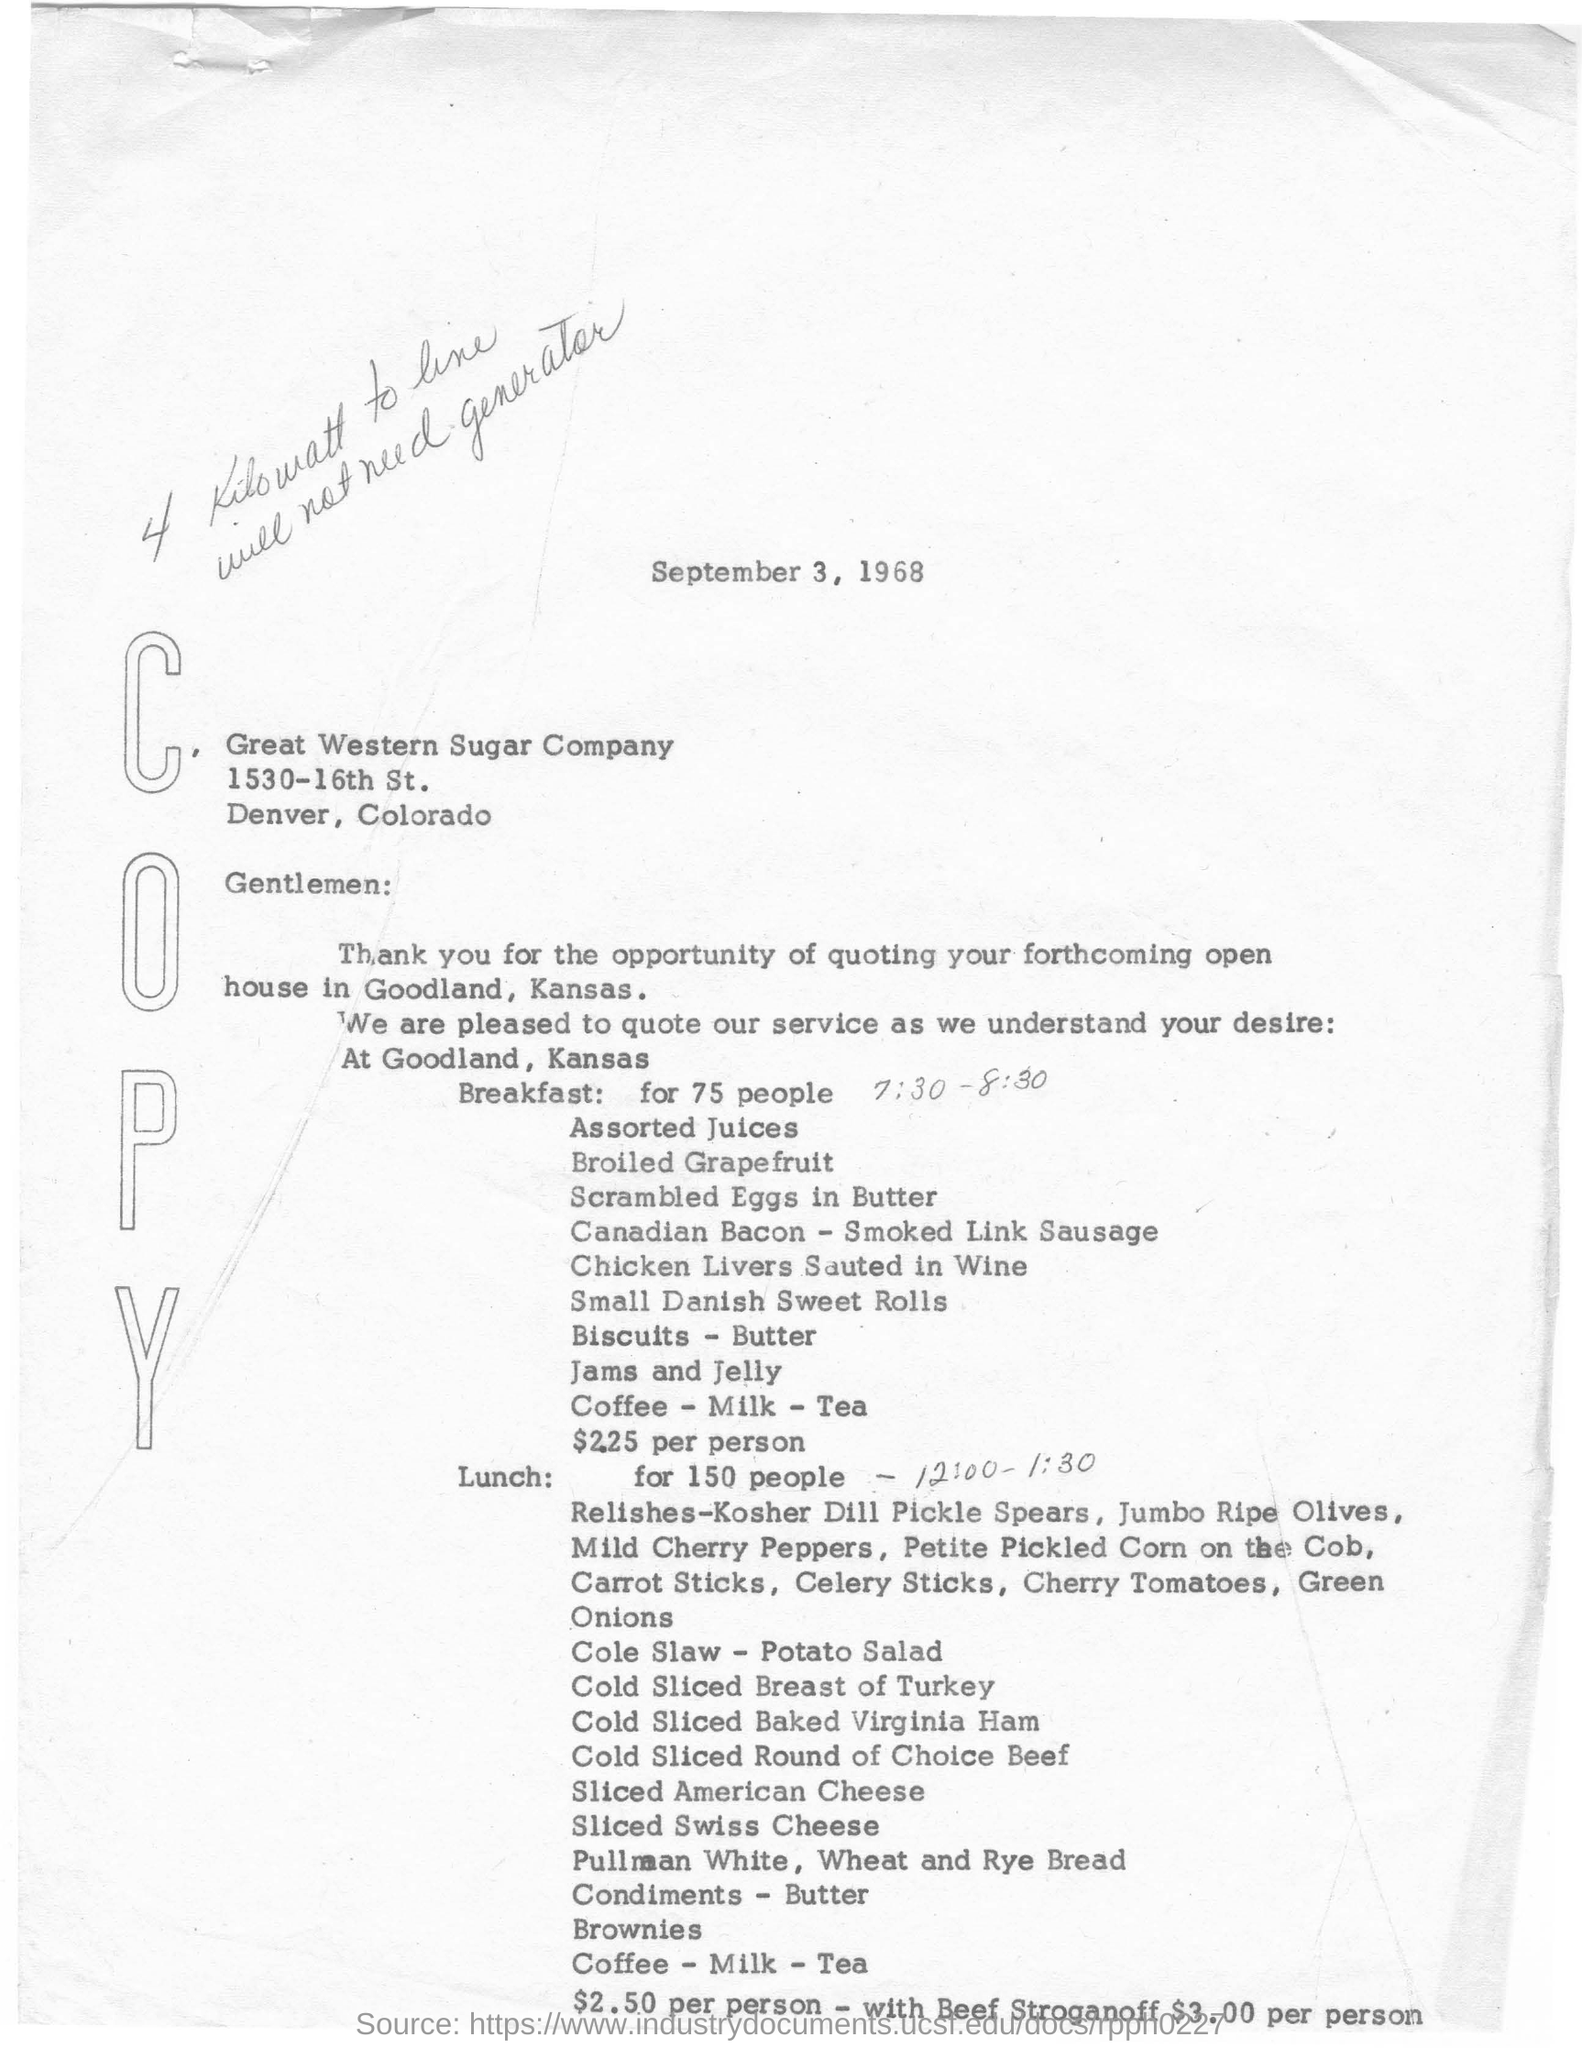Indicate a few pertinent items in this graphic. The name of the Sugar Company is Great Western. The breakfast was arranged for 75 people. The cost of the "Beef Stroganoff" lunch option for one person was $3.00. The provided time for breakfast was from 7:30 to 8:30. The company is situated in the state of Colorado. 